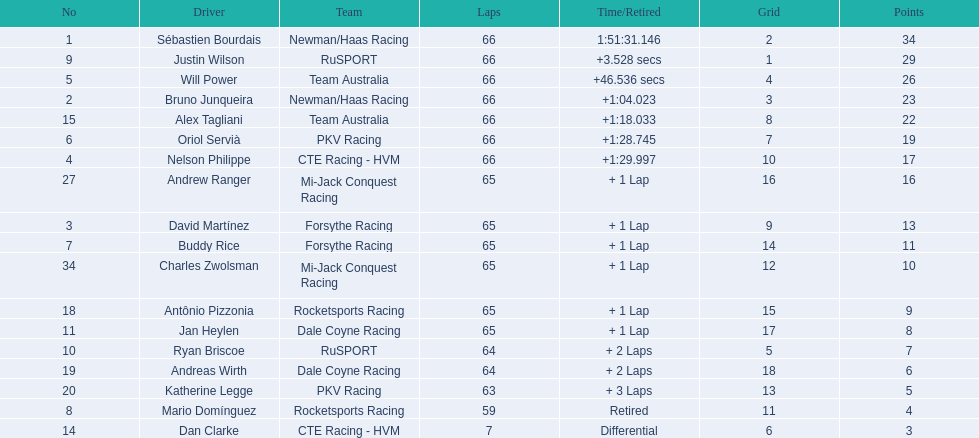Which people scored 29+ points? Sébastien Bourdais, Justin Wilson. Who scored higher? Sébastien Bourdais. 